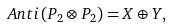<formula> <loc_0><loc_0><loc_500><loc_500>A n t i \left ( P _ { 2 } \otimes P _ { 2 } \right ) = X \oplus Y ,</formula> 